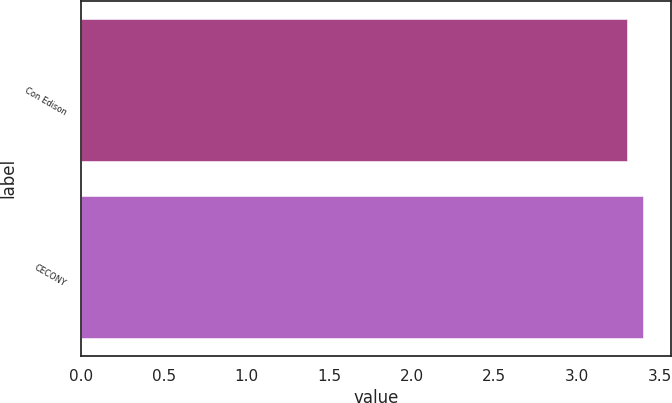Convert chart to OTSL. <chart><loc_0><loc_0><loc_500><loc_500><bar_chart><fcel>Con Edison<fcel>CECONY<nl><fcel>3.3<fcel>3.4<nl></chart> 